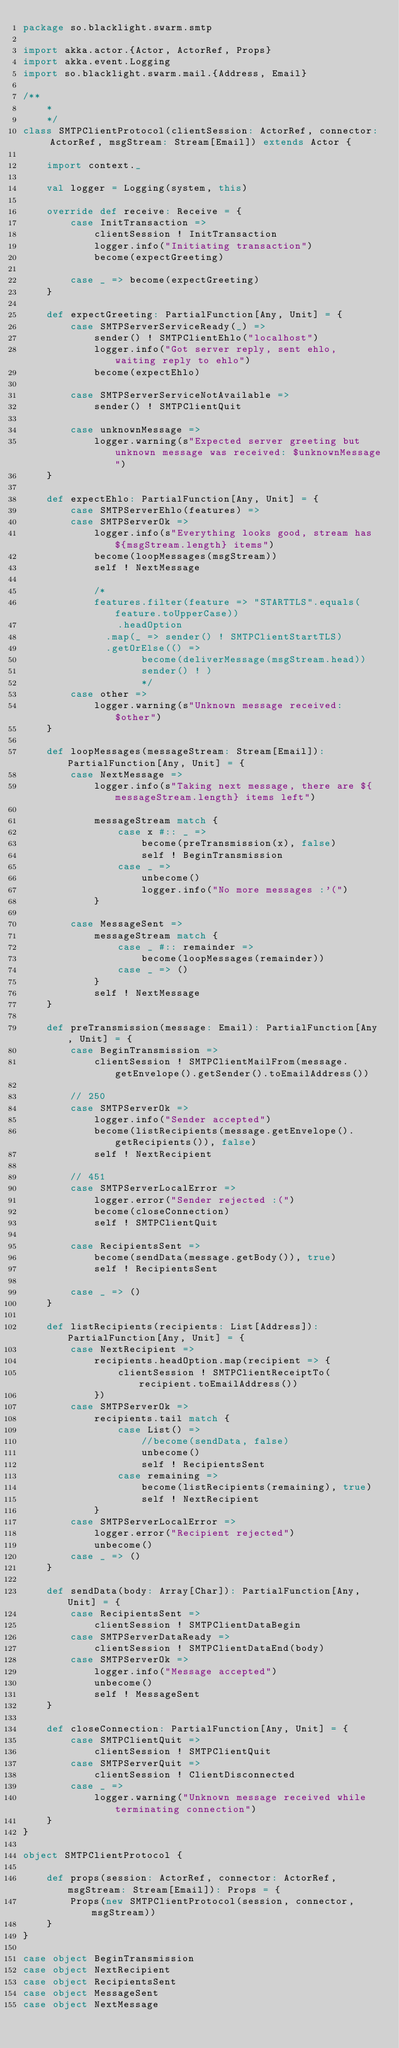Convert code to text. <code><loc_0><loc_0><loc_500><loc_500><_Scala_>package so.blacklight.swarm.smtp

import akka.actor.{Actor, ActorRef, Props}
import akka.event.Logging
import so.blacklight.swarm.mail.{Address, Email}

/**
	*
	*/
class SMTPClientProtocol(clientSession: ActorRef, connector: ActorRef, msgStream: Stream[Email]) extends Actor {

	import context._

	val logger = Logging(system, this)

	override def receive: Receive = {
		case InitTransaction =>
			clientSession ! InitTransaction
			logger.info("Initiating transaction")
			become(expectGreeting)

		case _ => become(expectGreeting)
	}

	def expectGreeting: PartialFunction[Any, Unit] = {
		case SMTPServerServiceReady(_) =>
			sender() ! SMTPClientEhlo("localhost")
			logger.info("Got server reply, sent ehlo, waiting reply to ehlo")
			become(expectEhlo)

		case SMTPServerServiceNotAvailable =>
			sender() ! SMTPClientQuit

		case unknownMessage =>
			logger.warning(s"Expected server greeting but unknown message was received: $unknownMessage")
	}

	def expectEhlo: PartialFunction[Any, Unit] = {
		case SMTPServerEhlo(features) =>
		case SMTPServerOk =>
			logger.info(s"Everything looks good, stream has ${msgStream.length} items")
			become(loopMessages(msgStream))
			self ! NextMessage

			/*
			features.filter(feature => "STARTTLS".equals(feature.toUpperCase))
				.headOption
			  .map(_ => sender() ! SMTPClientStartTLS)
			  .getOrElse(() =>
					become(deliverMessage(msgStream.head))
					sender() ! )
					*/
		case other =>
			logger.warning(s"Unknown message received: $other")
	}

	def loopMessages(messageStream: Stream[Email]): PartialFunction[Any, Unit] = {
		case NextMessage =>
			logger.info(s"Taking next message, there are ${messageStream.length} items left")

			messageStream match {
				case x #:: _ =>
					become(preTransmission(x), false)
					self ! BeginTransmission
				case _ =>
					unbecome()
					logger.info("No more messages :'(")
			}

		case MessageSent =>
			messageStream match {
				case _ #:: remainder =>
					become(loopMessages(remainder))
				case _ => ()
			}
			self ! NextMessage
	}

	def preTransmission(message: Email): PartialFunction[Any, Unit] = {
		case BeginTransmission =>
			clientSession ! SMTPClientMailFrom(message.getEnvelope().getSender().toEmailAddress())

		// 250
		case SMTPServerOk =>
			logger.info("Sender accepted")
			become(listRecipients(message.getEnvelope().getRecipients()), false)
			self ! NextRecipient

		// 451
		case SMTPServerLocalError =>
			logger.error("Sender rejected :(")
			become(closeConnection)
			self ! SMTPClientQuit

		case RecipientsSent =>
			become(sendData(message.getBody()), true)
			self ! RecipientsSent

		case _ => ()
	}

	def listRecipients(recipients: List[Address]): PartialFunction[Any, Unit] = {
		case NextRecipient =>
			recipients.headOption.map(recipient => {
				clientSession ! SMTPClientReceiptTo(recipient.toEmailAddress())
			})
		case SMTPServerOk =>
			recipients.tail match {
				case List() =>
					//become(sendData, false)
					unbecome()
					self ! RecipientsSent
				case remaining =>
					become(listRecipients(remaining), true)
					self ! NextRecipient
			}
		case SMTPServerLocalError =>
			logger.error("Recipient rejected")
			unbecome()
		case _ => ()
	}

	def sendData(body: Array[Char]): PartialFunction[Any, Unit] = {
		case RecipientsSent =>
			clientSession ! SMTPClientDataBegin
		case SMTPServerDataReady =>
			clientSession ! SMTPClientDataEnd(body)
		case SMTPServerOk =>
			logger.info("Message accepted")
			unbecome()
			self ! MessageSent
	}

	def closeConnection: PartialFunction[Any, Unit] = {
		case SMTPClientQuit =>
			clientSession ! SMTPClientQuit
		case SMTPServerQuit =>
			clientSession ! ClientDisconnected
		case _ =>
			logger.warning("Unknown message received while terminating connection")
	}
}

object SMTPClientProtocol {

	def props(session: ActorRef, connector: ActorRef, msgStream: Stream[Email]): Props = {
		Props(new SMTPClientProtocol(session, connector, msgStream))
	}
}

case object BeginTransmission
case object NextRecipient
case object RecipientsSent
case object MessageSent
case object NextMessage</code> 